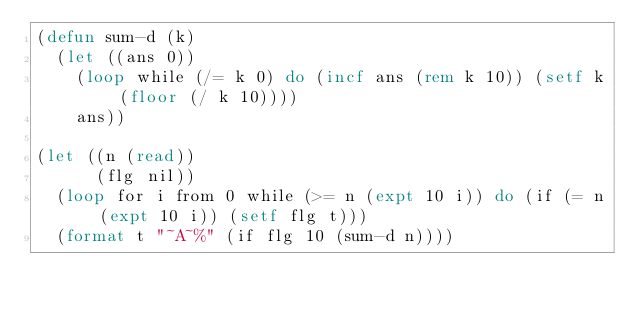<code> <loc_0><loc_0><loc_500><loc_500><_Lisp_>(defun sum-d (k)
  (let ((ans 0))
    (loop while (/= k 0) do (incf ans (rem k 10)) (setf k (floor (/ k 10))))
    ans))

(let ((n (read))
      (flg nil))
  (loop for i from 0 while (>= n (expt 10 i)) do (if (= n (expt 10 i)) (setf flg t)))
  (format t "~A~%" (if flg 10 (sum-d n))))
</code> 